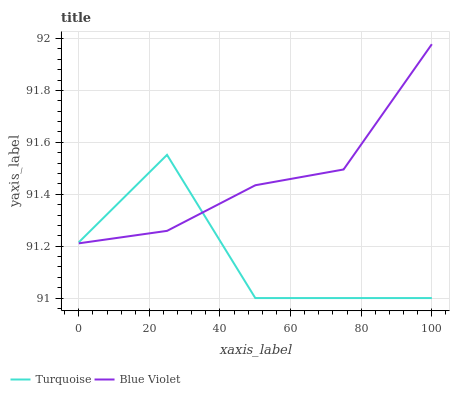Does Turquoise have the minimum area under the curve?
Answer yes or no. Yes. Does Blue Violet have the maximum area under the curve?
Answer yes or no. Yes. Does Blue Violet have the minimum area under the curve?
Answer yes or no. No. Is Blue Violet the smoothest?
Answer yes or no. Yes. Is Turquoise the roughest?
Answer yes or no. Yes. Is Blue Violet the roughest?
Answer yes or no. No. Does Turquoise have the lowest value?
Answer yes or no. Yes. Does Blue Violet have the lowest value?
Answer yes or no. No. Does Blue Violet have the highest value?
Answer yes or no. Yes. Does Turquoise intersect Blue Violet?
Answer yes or no. Yes. Is Turquoise less than Blue Violet?
Answer yes or no. No. Is Turquoise greater than Blue Violet?
Answer yes or no. No. 